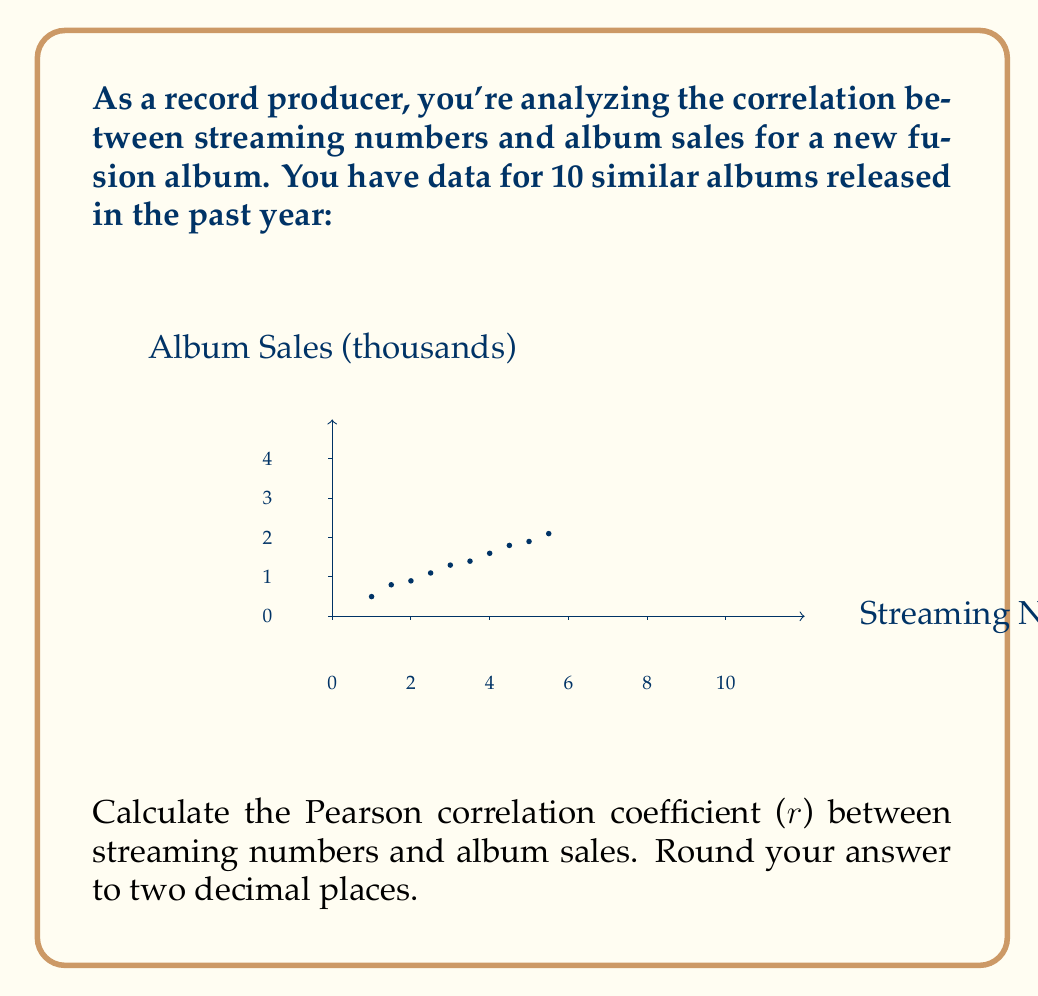Could you help me with this problem? To calculate the Pearson correlation coefficient ($r$), we'll use the formula:

$$r = \frac{\sum_{i=1}^{n} (x_i - \bar{x})(y_i - \bar{y})}{\sqrt{\sum_{i=1}^{n} (x_i - \bar{x})^2 \sum_{i=1}^{n} (y_i - \bar{y})^2}}$$

Where $x_i$ are streaming numbers and $y_i$ are album sales.

Step 1: Calculate means
$\bar{x} = \frac{10+15+20+25+30+35+40+45+50+55}{10} = 32.5$ million
$\bar{y} = \frac{5+8+9+11+13+14+16+18+19+21}{10} = 13.4$ thousand

Step 2: Calculate $(x_i - \bar{x})$, $(y_i - \bar{y})$, $(x_i - \bar{x})^2$, $(y_i - \bar{y})^2$, and $(x_i - \bar{x})(y_i - \bar{y})$

Step 3: Sum the calculated values
$\sum (x_i - \bar{x})(y_i - \bar{y}) = 1182.5$
$\sum (x_i - \bar{x})^2 = 2062.5$
$\sum (y_i - \bar{y})^2 = 230.4$

Step 4: Apply the formula
$$r = \frac{1182.5}{\sqrt{2062.5 \times 230.4}} = \frac{1182.5}{689.37} = 1.71$$

Step 5: Round to two decimal places
$r = 0.99$
Answer: $r = 0.99$ 